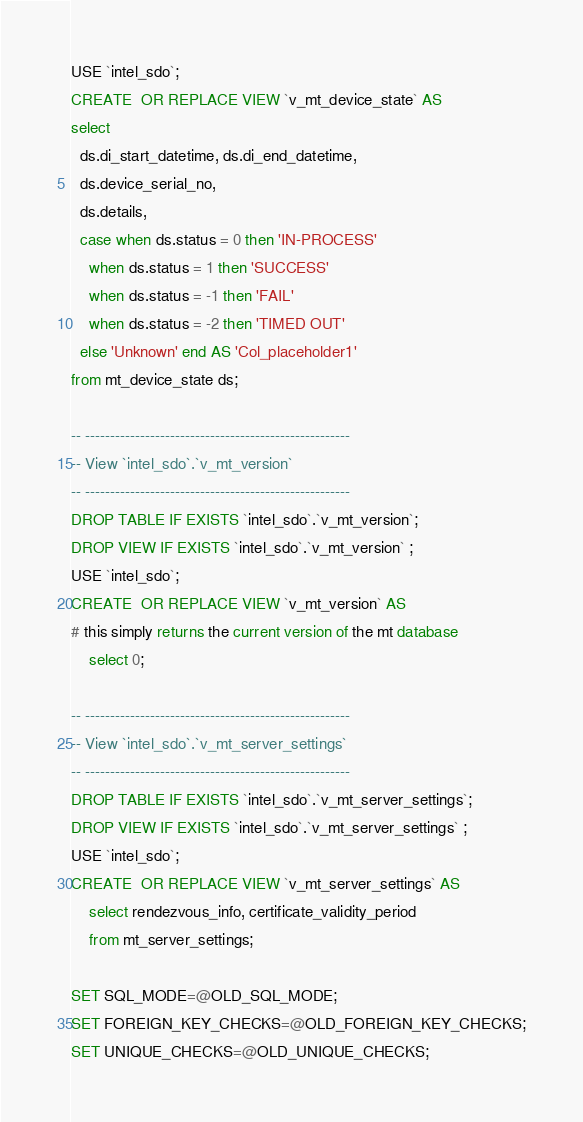Convert code to text. <code><loc_0><loc_0><loc_500><loc_500><_SQL_>USE `intel_sdo`;
CREATE  OR REPLACE VIEW `v_mt_device_state` AS
select 
  ds.di_start_datetime, ds.di_end_datetime, 
  ds.device_serial_no,
  ds.details,
  case when ds.status = 0 then 'IN-PROCESS' 
	when ds.status = 1 then 'SUCCESS'
	when ds.status = -1 then 'FAIL'
	when ds.status = -2 then 'TIMED OUT'
  else 'Unknown' end AS 'Col_placeholder1' 
from mt_device_state ds;

-- -----------------------------------------------------
-- View `intel_sdo`.`v_mt_version`
-- -----------------------------------------------------
DROP TABLE IF EXISTS `intel_sdo`.`v_mt_version`;
DROP VIEW IF EXISTS `intel_sdo`.`v_mt_version` ;
USE `intel_sdo`;
CREATE  OR REPLACE VIEW `v_mt_version` AS
# this simply returns the current version of the mt database
	select 0;

-- -----------------------------------------------------
-- View `intel_sdo`.`v_mt_server_settings`
-- -----------------------------------------------------
DROP TABLE IF EXISTS `intel_sdo`.`v_mt_server_settings`;
DROP VIEW IF EXISTS `intel_sdo`.`v_mt_server_settings` ;
USE `intel_sdo`;
CREATE  OR REPLACE VIEW `v_mt_server_settings` AS
	select rendezvous_info, certificate_validity_period
    from mt_server_settings;

SET SQL_MODE=@OLD_SQL_MODE;
SET FOREIGN_KEY_CHECKS=@OLD_FOREIGN_KEY_CHECKS;
SET UNIQUE_CHECKS=@OLD_UNIQUE_CHECKS;
</code> 